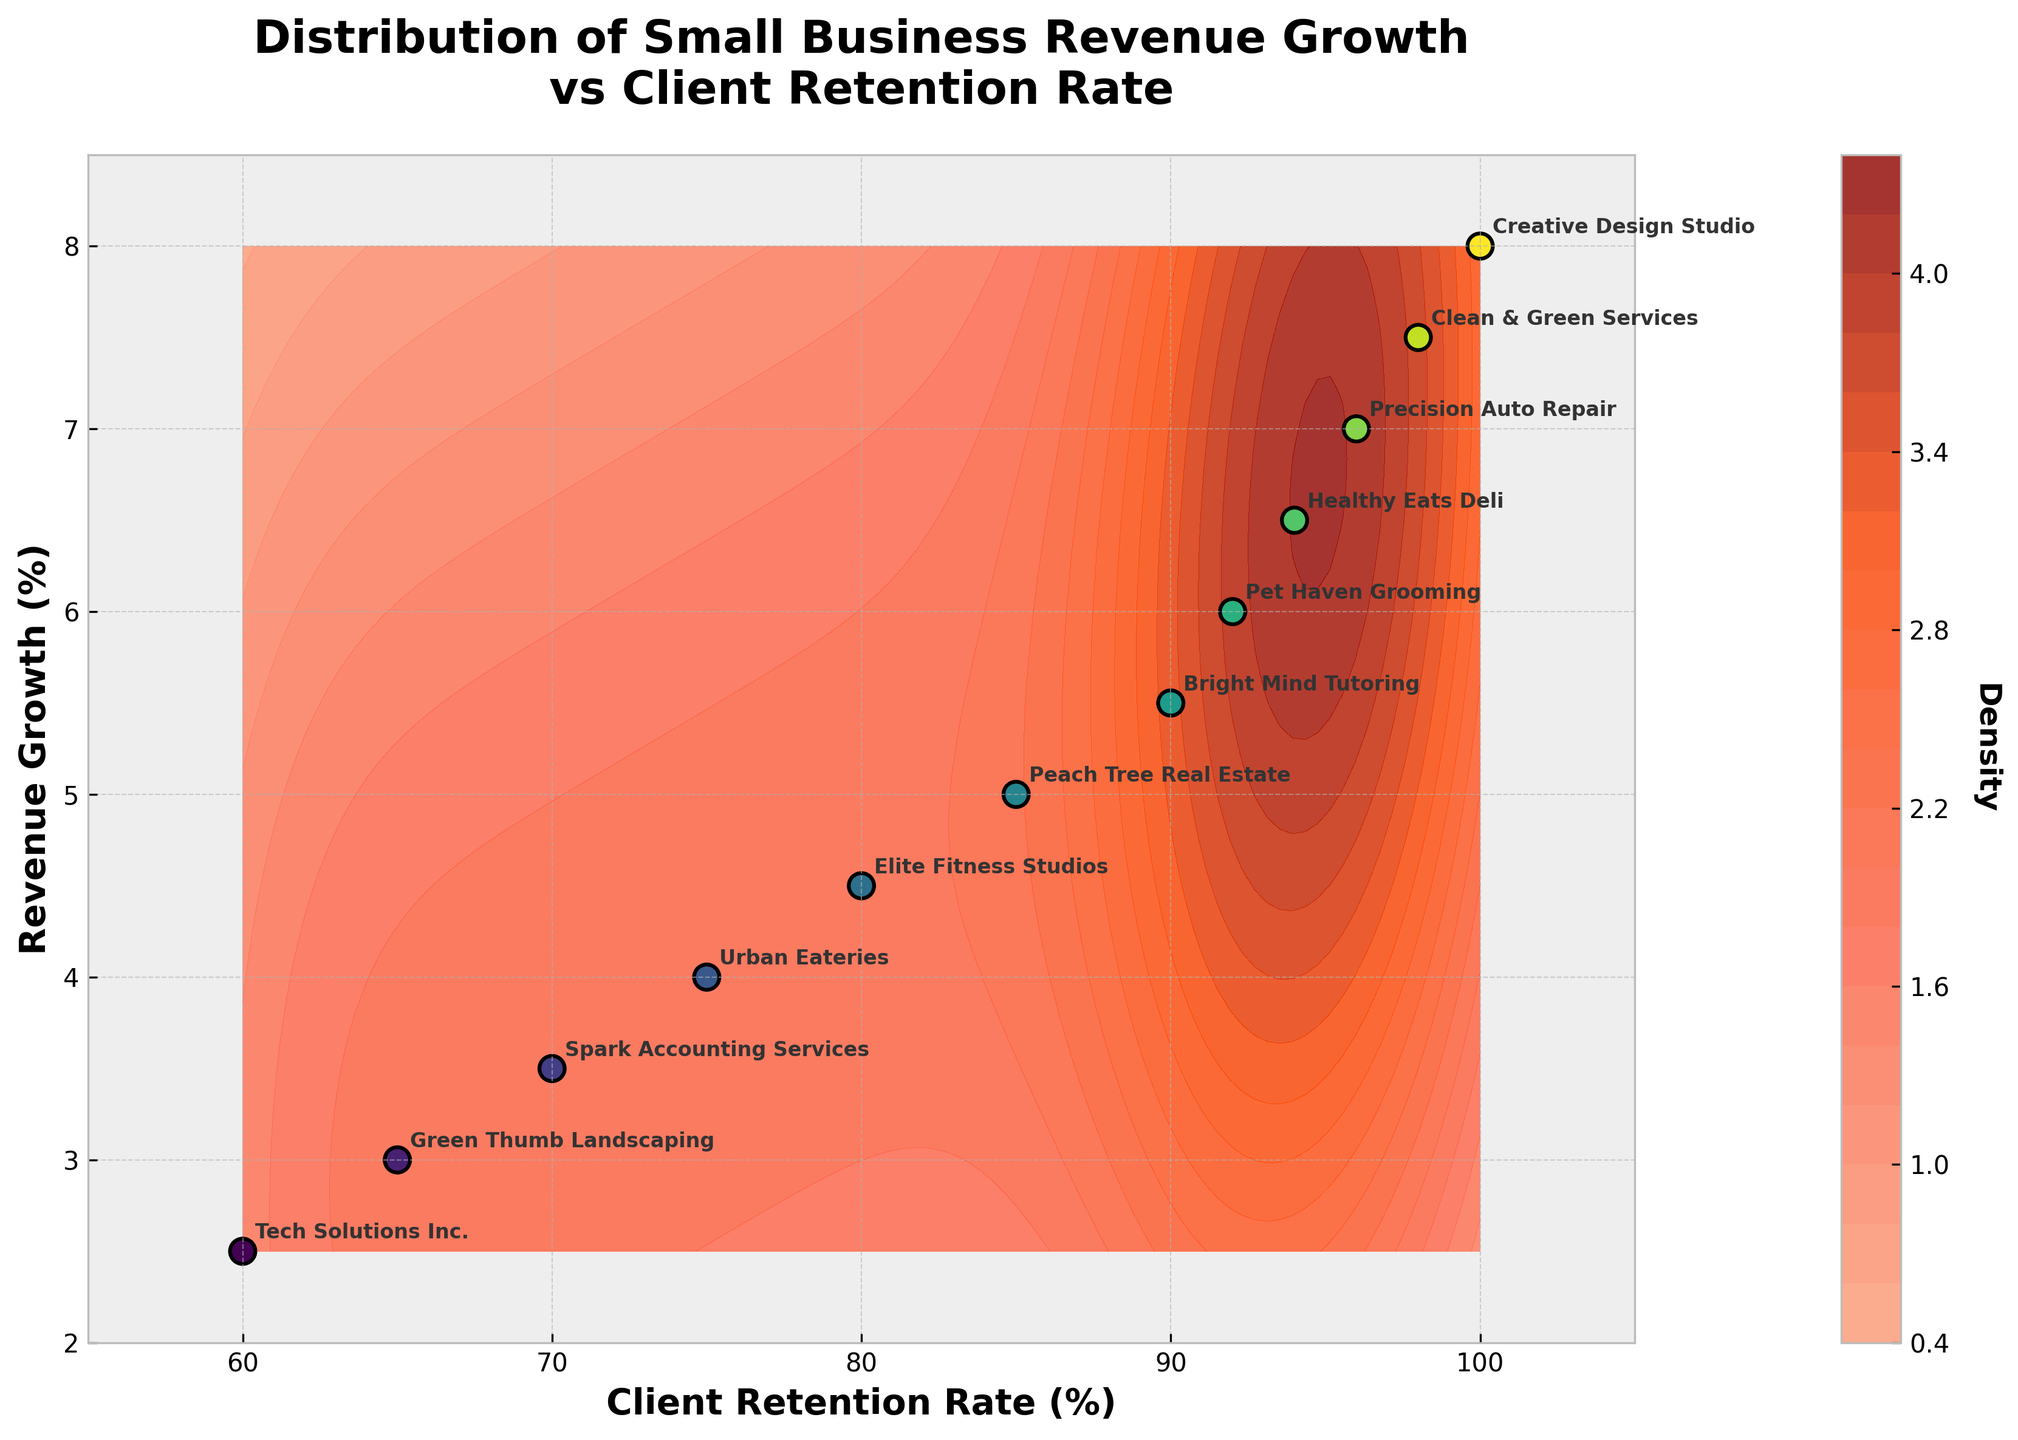What is the title of the figure? The title of the figure is prominently displayed at the top, indicating the purpose of the plot.
Answer: Distribution of Small Business Revenue Growth vs Client Retention Rate How many data points are plotted on the scatter plot? Each company is represented by one point in the scatter plot, and there are 12 companies listed, thus 12 data points.
Answer: 12 What is the revenue growth for Elite Fitness Studios? Locate Elite Fitness Studios on the plot. It corresponds to a client retention rate of 80%, where the revenue growth percentage can be read.
Answer: 4.5% Which company has the highest revenue growth rate? Identify the company at the highest y-axis point on the scatter plot.
Answer: Creative Design Studio What is the approximate range of client retention rates shown on the x-axis? The x-axis starts just below 60% and extends slightly above 100%.
Answer: 55% to 105% What is the color scheme used for density representation in the contour plot? The density is represented by a gradient from light salmon color to deep red.
Answer: Light salmon to deep red How is the relationship between client retention rate and revenue growth visually represented? Describe how the scatter points and contours suggest the relationship between the two variables. Data points higher on the plot (indicating higher revenue growth) all have higher client retention rates, suggesting a positive correlation.
Answer: Positive correlation Compare the revenue growth of Urban Eateries and Bright Mind Tutoring. Urban Eateries, with a retention rate of 75%, has lower revenue growth than Bright Mind Tutoring, which has a retention rate of 90%. Check the y-axis positions for verification.
Answer: Urban Eateries: 4.0%, Bright Mind Tutoring: 5.5% Why might companies with higher client retention rates show increased revenue growth in this figure? Discuss the logical interpretation that increased client retention likely leads to more consistent revenue streams and sales opportunities. The visual plot suggests this strong positive relationship.
Answer: Higher retention tends to correlate with consistent and increasing customer revenue 